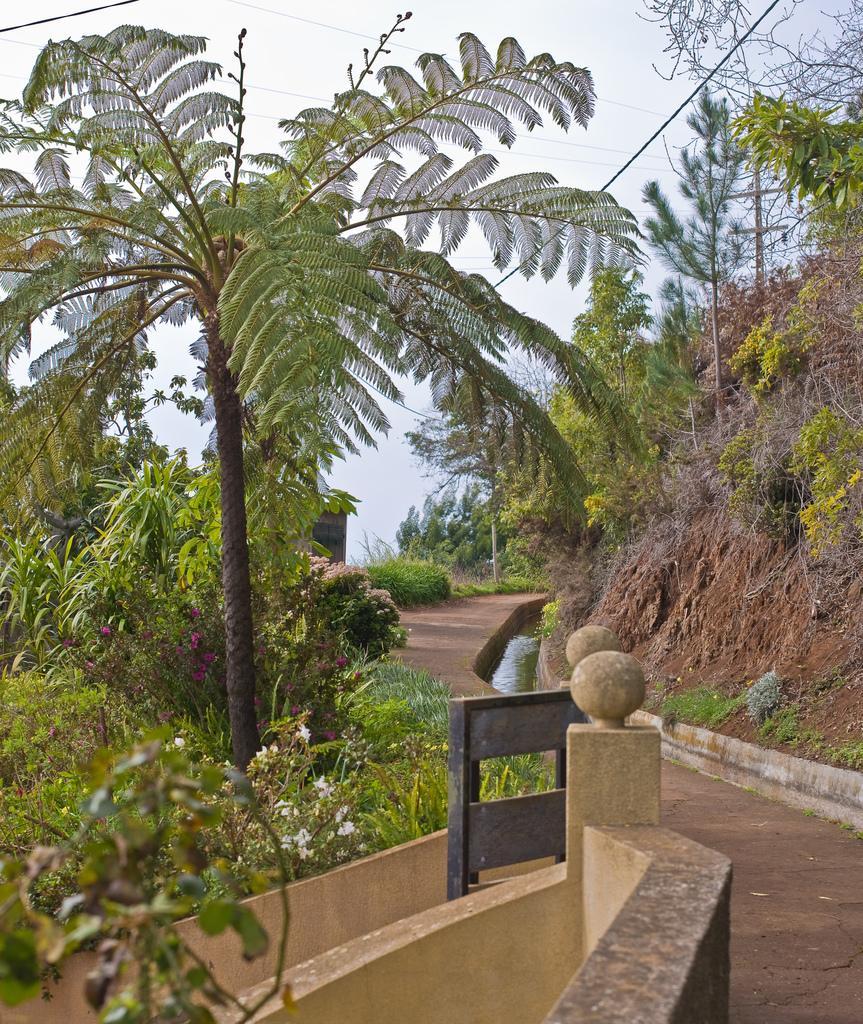Can you describe this image briefly? Here we can see plants, flowers, trees, and water. In the background there is sky. 